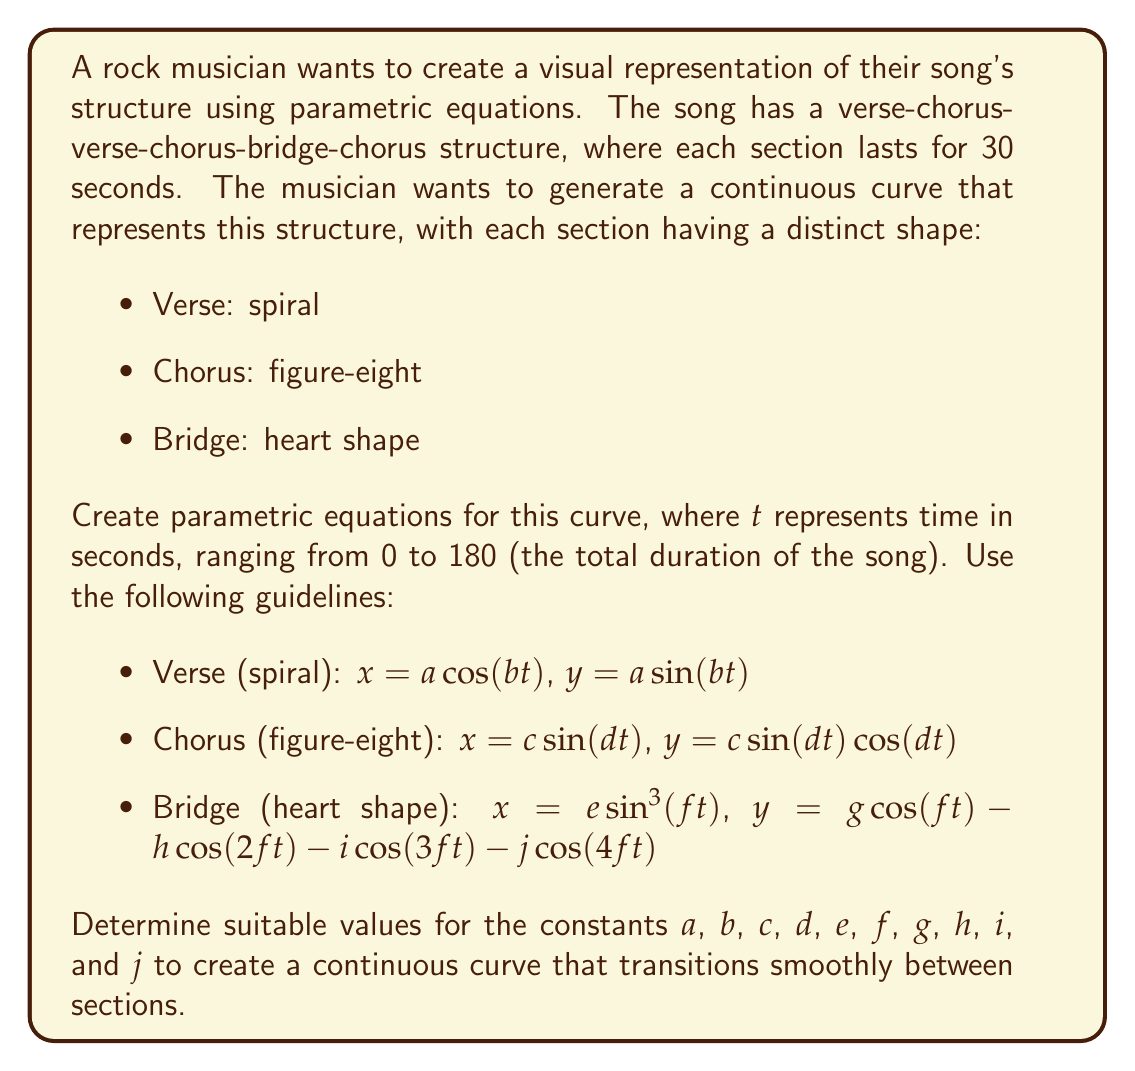Help me with this question. To solve this problem, we need to create parametric equations that represent each section of the song and ensure smooth transitions between them. Let's break it down step by step:

1. First, we need to define the time intervals for each section:
   - Verse 1: 0 ≤ t < 30
   - Chorus 1: 30 ≤ t < 60
   - Verse 2: 60 ≤ t < 90
   - Chorus 2: 90 ≤ t < 120
   - Bridge: 120 ≤ t < 150
   - Chorus 3: 150 ≤ t ≤ 180

2. Now, let's define the parametric equations for each section:

   Verse (spiral):
   $$x = a\cos(b(t-k))$$
   $$y = a\sin(b(t-k))$$
   
   Chorus (figure-eight):
   $$x = c\sin(d(t-k))$$
   $$y = c\sin(d(t-k))\cos(d(t-k))$$
   
   Bridge (heart shape):
   $$x = e\sin^3(f(t-k))$$
   $$y = g\cos(f(t-k)) - h\cos(2f(t-k)) - i\cos(3f(t-k)) - j\cos(4f(t-k))$$

   Where $k$ is the starting time of each section.

3. To ensure smooth transitions, we need to choose appropriate values for the constants. Let's select the following values:

   $a = 5$, $b = 0.4\pi$
   $c = 5$, $d = 0.2\pi$
   $e = 16$, $f = 0.1\pi$, $g = 13$, $h = 5$, $i = 2$, $j = 1$

4. Now, we can write the complete parametric equations:

   $$x(t) = \begin{cases}
   5\cos(0.4\pi t) & 0 \leq t < 30 \\
   5\sin(0.2\pi(t-30)) & 30 \leq t < 60 \\
   5\cos(0.4\pi(t-60)) & 60 \leq t < 90 \\
   5\sin(0.2\pi(t-90)) & 90 \leq t < 120 \\
   16\sin^3(0.1\pi(t-120)) & 120 \leq t < 150 \\
   5\sin(0.2\pi(t-150)) & 150 \leq t \leq 180
   \end{cases}$$

   $$y(t) = \begin{cases}
   5\sin(0.4\pi t) & 0 \leq t < 30 \\
   5\sin(0.2\pi(t-30))\cos(0.2\pi(t-30)) & 30 \leq t < 60 \\
   5\sin(0.4\pi(t-60)) & 60 \leq t < 90 \\
   5\sin(0.2\pi(t-90))\cos(0.2\pi(t-90)) & 90 \leq t < 120 \\
   13\cos(0.1\pi(t-120)) - 5\cos(0.2\pi(t-120)) - 2\cos(0.3\pi(t-120)) - \cos(0.4\pi(t-120)) & 120 \leq t < 150 \\
   5\sin(0.2\pi(t-150))\cos(0.2\pi(t-150)) & 150 \leq t \leq 180
   \end{cases}$$

These equations will create a continuous curve that represents the song structure, with smooth transitions between sections.
Answer: The parametric equations representing the song structure are:

$$x(t) = \begin{cases}
5\cos(0.4\pi t) & 0 \leq t < 30 \\
5\sin(0.2\pi(t-30)) & 30 \leq t < 60 \\
5\cos(0.4\pi(t-60)) & 60 \leq t < 90 \\
5\sin(0.2\pi(t-90)) & 90 \leq t < 120 \\
16\sin^3(0.1\pi(t-120)) & 120 \leq t < 150 \\
5\sin(0.2\pi(t-150)) & 150 \leq t \leq 180
\end{cases}$$

$$y(t) = \begin{cases}
5\sin(0.4\pi t) & 0 \leq t < 30 \\
5\sin(0.2\pi(t-30))\cos(0.2\pi(t-30)) & 30 \leq t < 60 \\
5\sin(0.4\pi(t-60)) & 60 \leq t < 90 \\
5\sin(0.2\pi(t-90))\cos(0.2\pi(t-90)) & 90 \leq t < 120 \\
13\cos(0.1\pi(t-120)) - 5\cos(0.2\pi(t-120)) - 2\cos(0.3\pi(t-120)) - \cos(0.4\pi(t-120)) & 120 \leq t < 150 \\
5\sin(0.2\pi(t-150))\cos(0.2\pi(t-150)) & 150 \leq t \leq 180
\end{cases}$$

Where $t$ represents time in seconds, ranging from 0 to 180. 